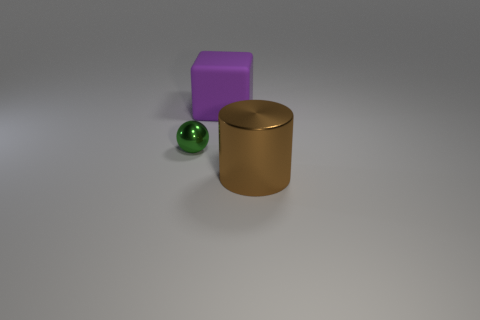Subtract all red spheres. Subtract all blue cylinders. How many spheres are left? 1 Subtract all purple cubes. How many brown spheres are left? 0 Add 2 blues. How many small objects exist? 0 Subtract all small red shiny objects. Subtract all brown cylinders. How many objects are left? 2 Add 3 big shiny objects. How many big shiny objects are left? 4 Add 2 cylinders. How many cylinders exist? 3 Add 1 small shiny objects. How many objects exist? 4 Subtract 0 cyan blocks. How many objects are left? 3 Subtract all blocks. How many objects are left? 2 Subtract 1 blocks. How many blocks are left? 0 